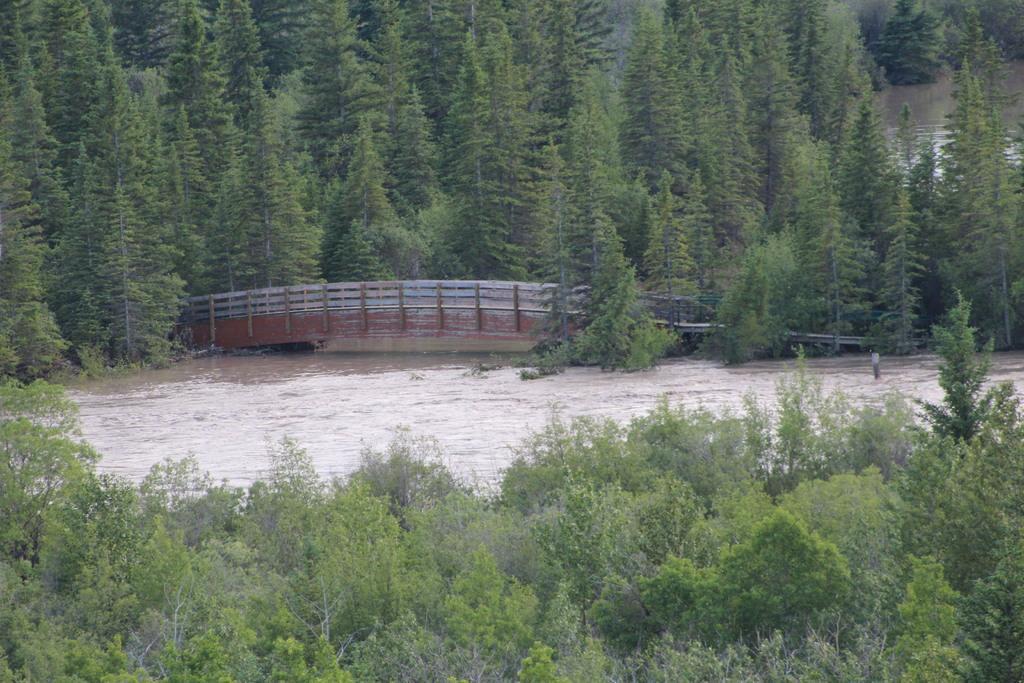Please provide a concise description of this image. In this picture I see number of trees in front and in the background. In the middle of this picture I see the water and a bridge. 